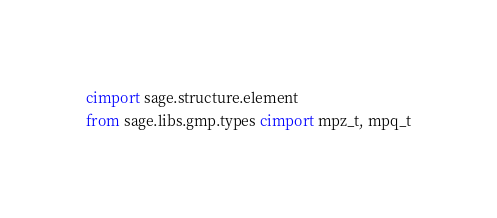Convert code to text. <code><loc_0><loc_0><loc_500><loc_500><_Cython_>cimport sage.structure.element
from sage.libs.gmp.types cimport mpz_t, mpq_t</code> 